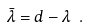Convert formula to latex. <formula><loc_0><loc_0><loc_500><loc_500>\bar { \lambda } = d - \lambda \ .</formula> 